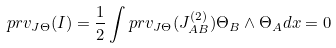<formula> <loc_0><loc_0><loc_500><loc_500>p r v _ { J \Theta } ( I ) = \frac { 1 } { 2 } \int p r v _ { J \Theta } ( J _ { A B } ^ { ( 2 ) } ) \Theta _ { B } \wedge \Theta _ { A } d x = 0</formula> 